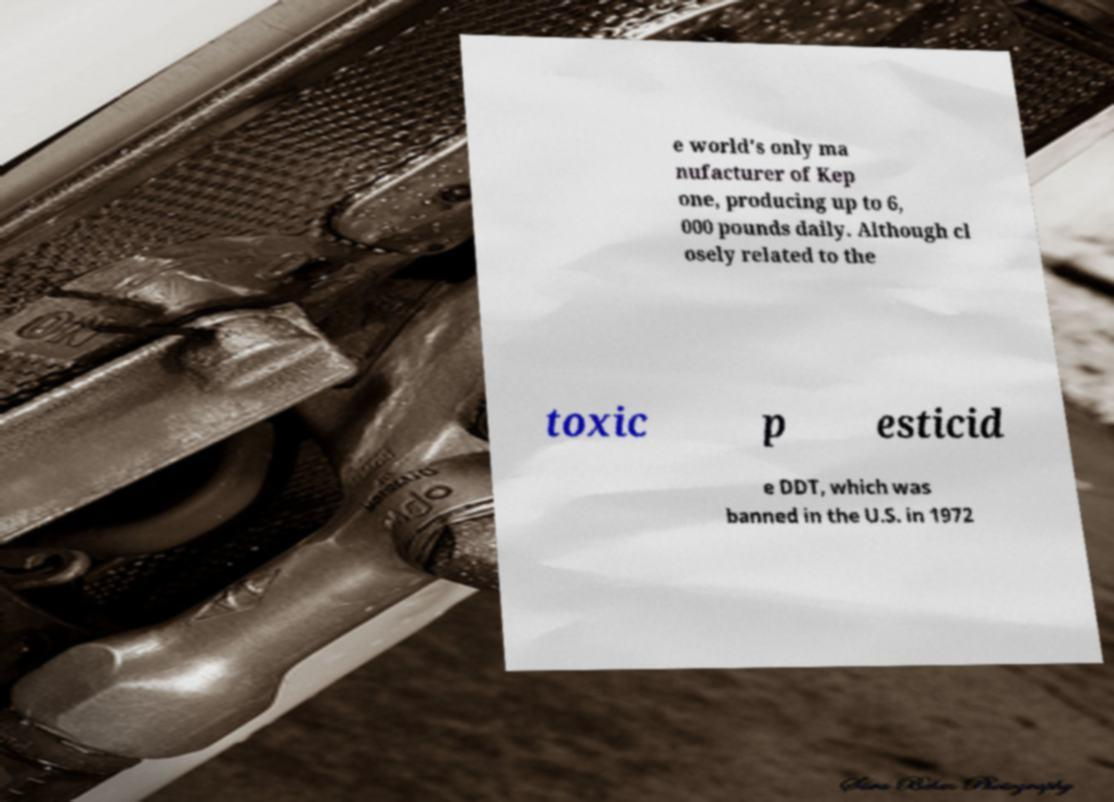For documentation purposes, I need the text within this image transcribed. Could you provide that? e world's only ma nufacturer of Kep one, producing up to 6, 000 pounds daily. Although cl osely related to the toxic p esticid e DDT, which was banned in the U.S. in 1972 